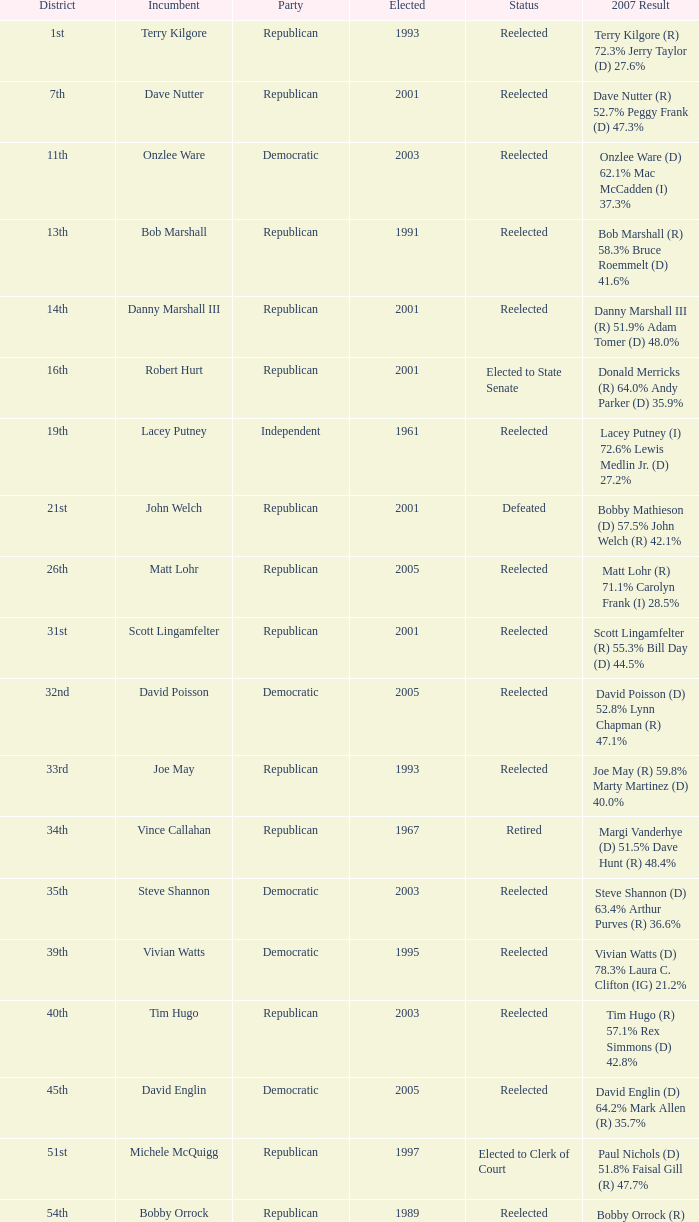For how many elections has incumbent onzlee ware been successful? 1.0. 